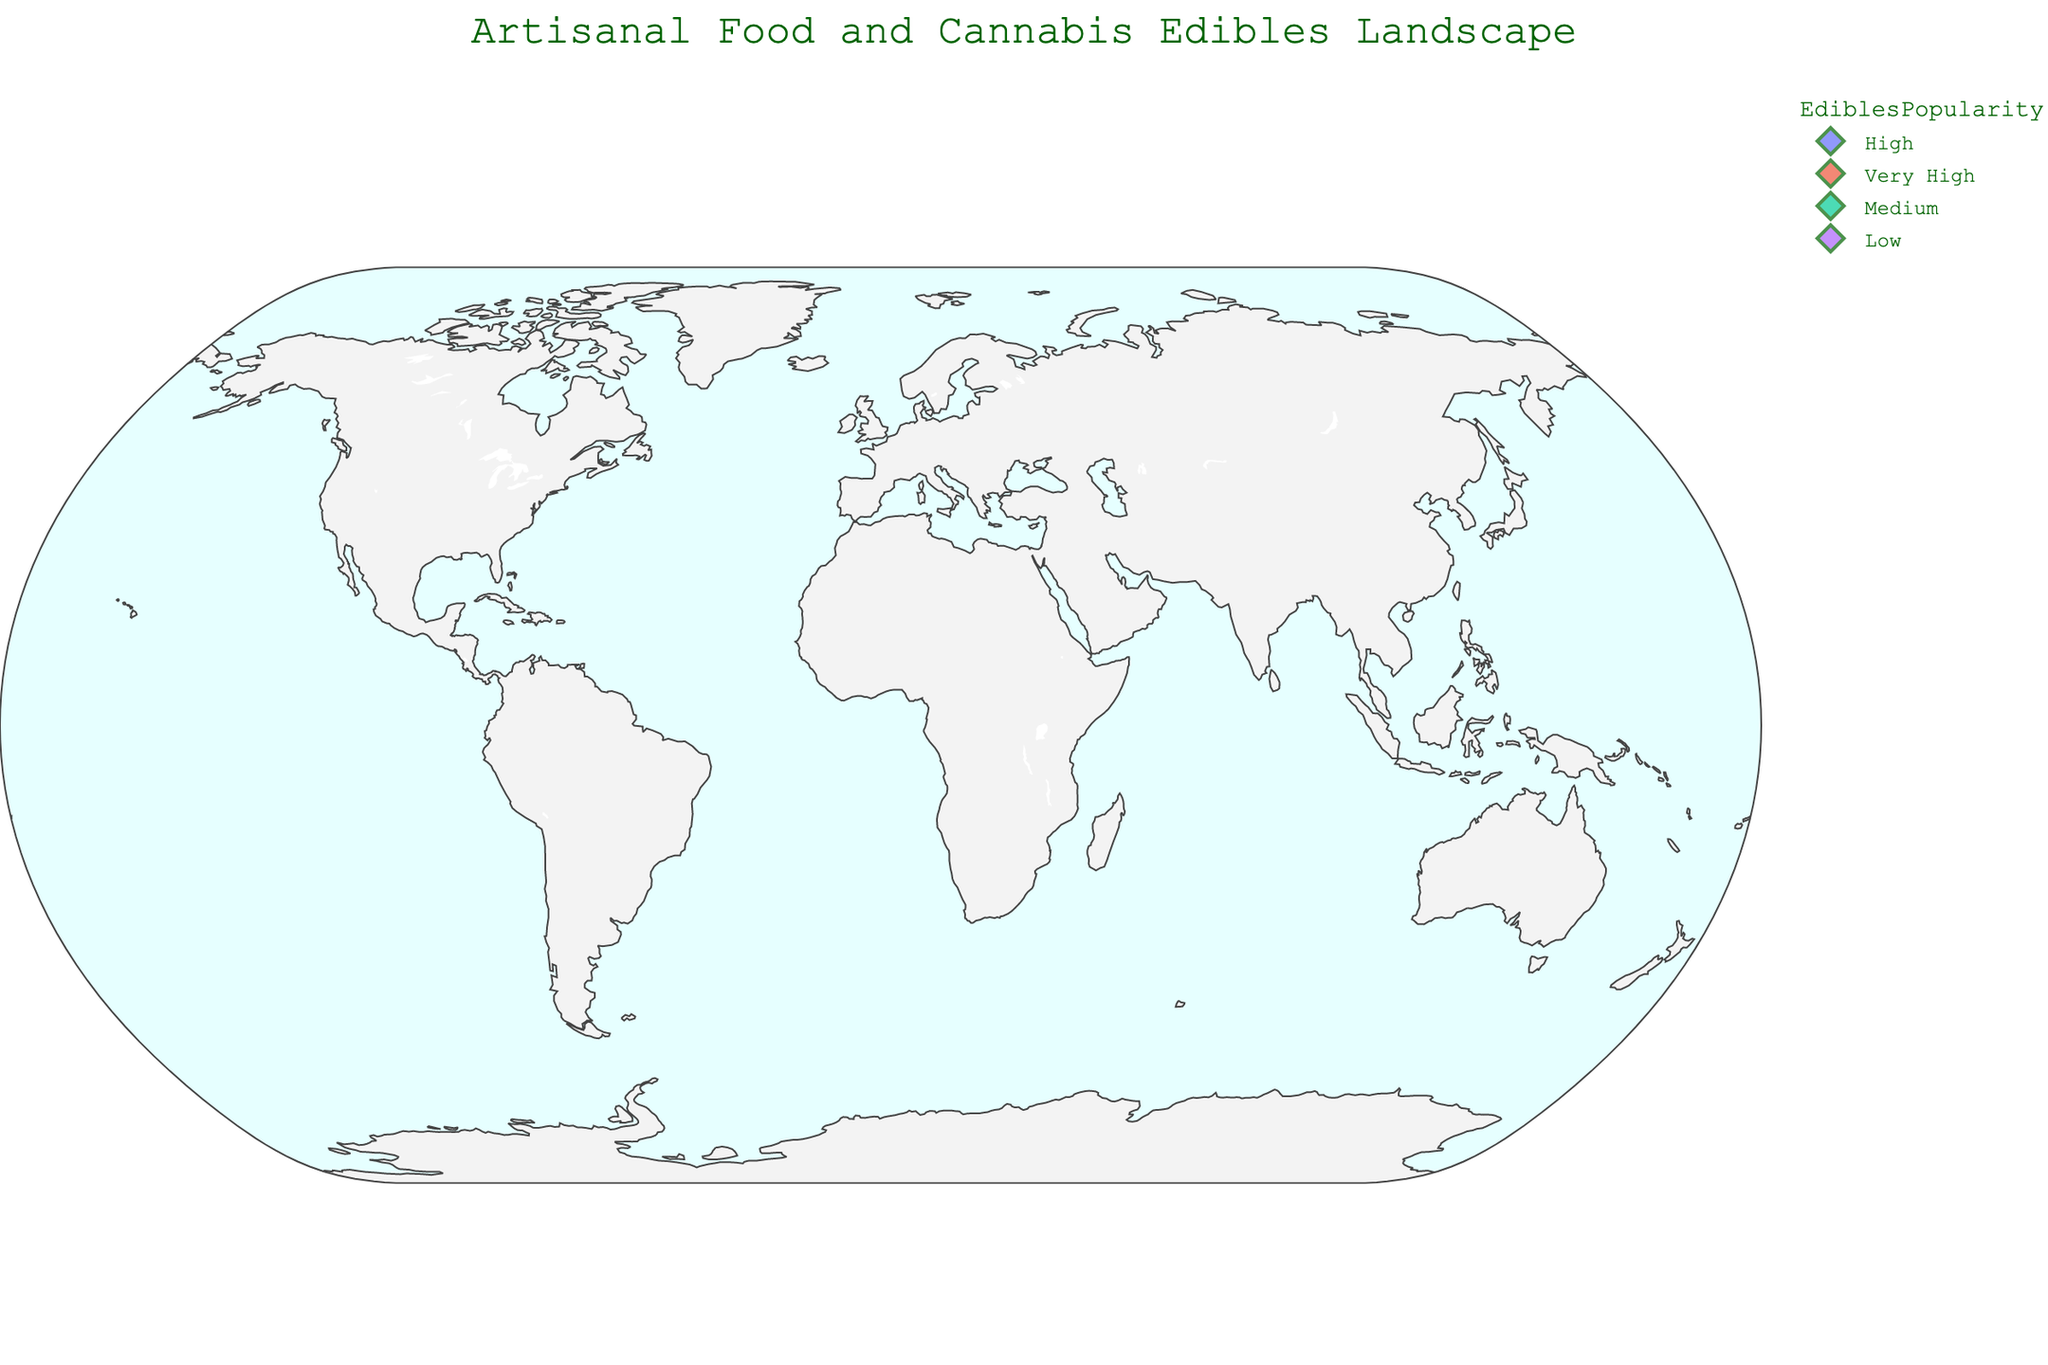Which city has the highest concentration of artisanal businesses? By looking at the plot, the bubble representing the size of the concentration is largest for New York City.
Answer: New York City Which cities have "Very High" Edibles Popularity? The bubbles with "Very High" Edibles Popularity are Portland and Amsterdam, distinguished by their color.
Answer: Portland and Amsterdam Compare the number of artisanal businesses between San Francisco and Seattle. Which city has more? The plot shows the size of the bubbles, and by comparing the sizes, San Francisco has a larger bubble than Seattle.
Answer: San Francisco Is there any city with high Edibles Popularity but illegal cannabis? From the hover data, we can see that all cities with high Edibles Popularity have legal or decriminalized cannabis but not illegal.
Answer: No How does the concentration of artisanal businesses in Legal cannabis cities compare with cities having Illegal or Decriminalized cannabis? Check the total sizes of the bubbles for cities with Legal cannabis vs those with Illegal or Decriminalized cannabis. Legal cannabis cities like New York, San Francisco, and Los Angeles have considerably more artisanal businesses.
Answer: Legal cities have more Which cities with Legal cannabis have a Medium Edibles Popularity? By hovering over the bubbles, Los Angeles, Boston, and Toronto show Medium Edibles Popularity with Legal cannabis status.
Answer: Los Angeles, Boston, Toronto What is the trend in Edibles Popularity among cities with the highest concentration of artisanal businesses? New York City, which has the highest concentration of artisanal businesses, shows low Edibles Popularity, indicating that there is not always a direct correlation between high concentration and high popularity of edibles.
Answer: Low Which city has the smallest concentration of artisanal businesses and what is the cannabis legality and edibles popularity there? By identifying the smallest bubble on the plot, Amsterdam has the smallest concentration with decriminalized cannabis and very high Edibles Popularity.
Answer: Amsterdam, Decriminalized, Very High How do the artisanal business concentrations compare between European and North American cities? European cities like London, Amsterdam, Berlin, Barcelona have smaller bubble sizes compared to North American cities like New York, San Francisco, and Los Angeles, indicating lower concentrations of artisanal businesses in European cities.
Answer: North American cities have higher concentrations of artisanal businesses Which city has a higher concentration of artisanal businesses: Chicago or Vancouver? By comparing the bubble sizes, Chicago has a higher concentration than Vancouver.
Answer: Chicago 